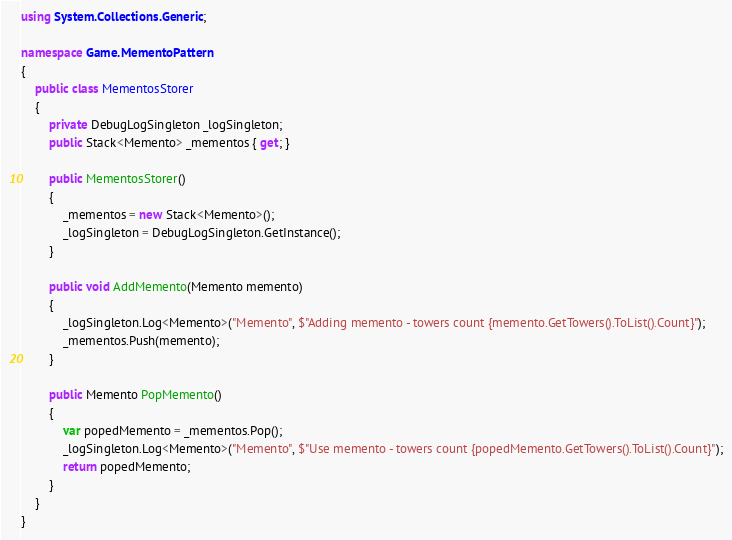<code> <loc_0><loc_0><loc_500><loc_500><_C#_>using System.Collections.Generic;

namespace Game.MementoPattern
{
    public class MementosStorer
    {
        private DebugLogSingleton _logSingleton;
        public Stack<Memento> _mementos { get; }

        public MementosStorer()
        {
            _mementos = new Stack<Memento>();
            _logSingleton = DebugLogSingleton.GetInstance();
        }

        public void AddMemento(Memento memento)
        {
            _logSingleton.Log<Memento>("Memento", $"Adding memento - towers count {memento.GetTowers().ToList().Count}");
            _mementos.Push(memento);
        }

        public Memento PopMemento()
        {
            var popedMemento = _mementos.Pop();
            _logSingleton.Log<Memento>("Memento", $"Use memento - towers count {popedMemento.GetTowers().ToList().Count}");
            return popedMemento;
        }
    }
}</code> 